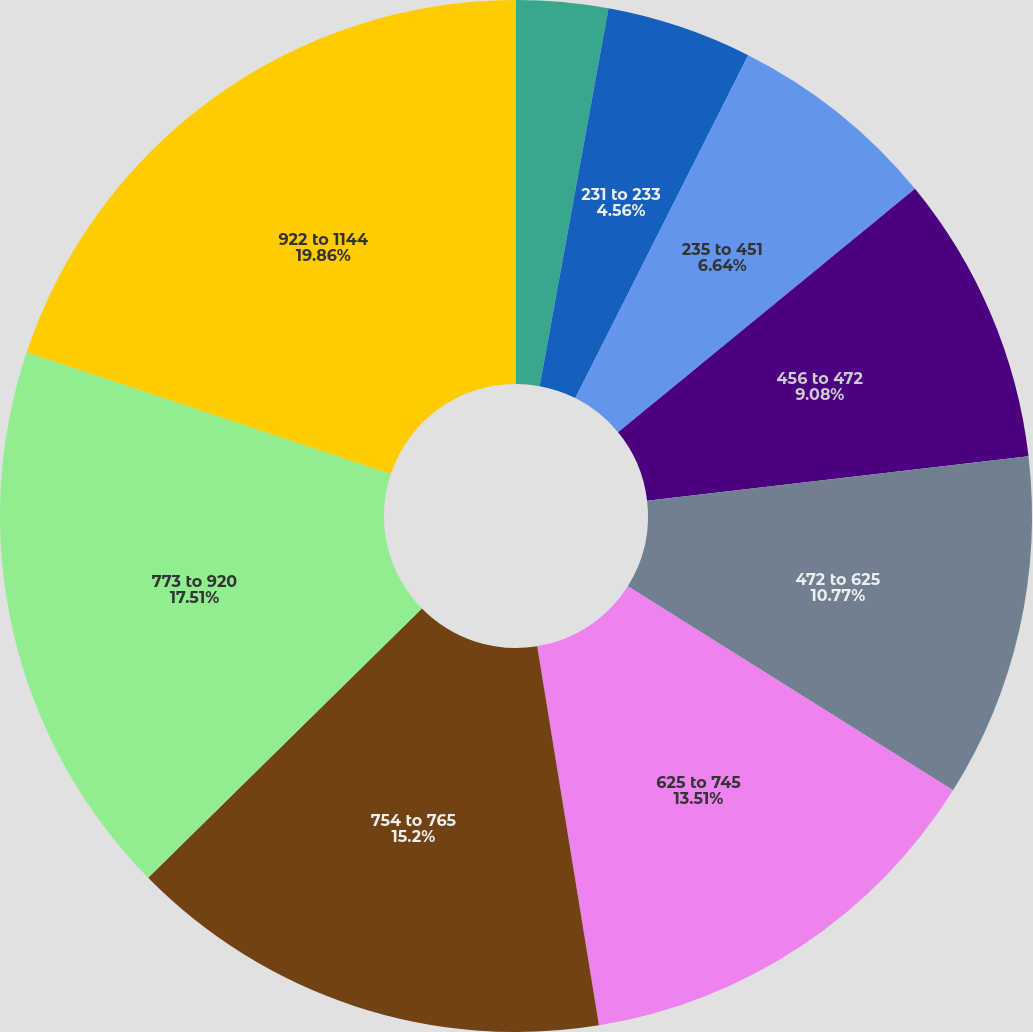Convert chart to OTSL. <chart><loc_0><loc_0><loc_500><loc_500><pie_chart><fcel>133 to 229<fcel>231 to 233<fcel>235 to 451<fcel>456 to 472<fcel>472 to 625<fcel>625 to 745<fcel>754 to 765<fcel>773 to 920<fcel>922 to 1144<nl><fcel>2.87%<fcel>4.56%<fcel>6.64%<fcel>9.08%<fcel>10.77%<fcel>13.51%<fcel>15.2%<fcel>17.51%<fcel>19.86%<nl></chart> 